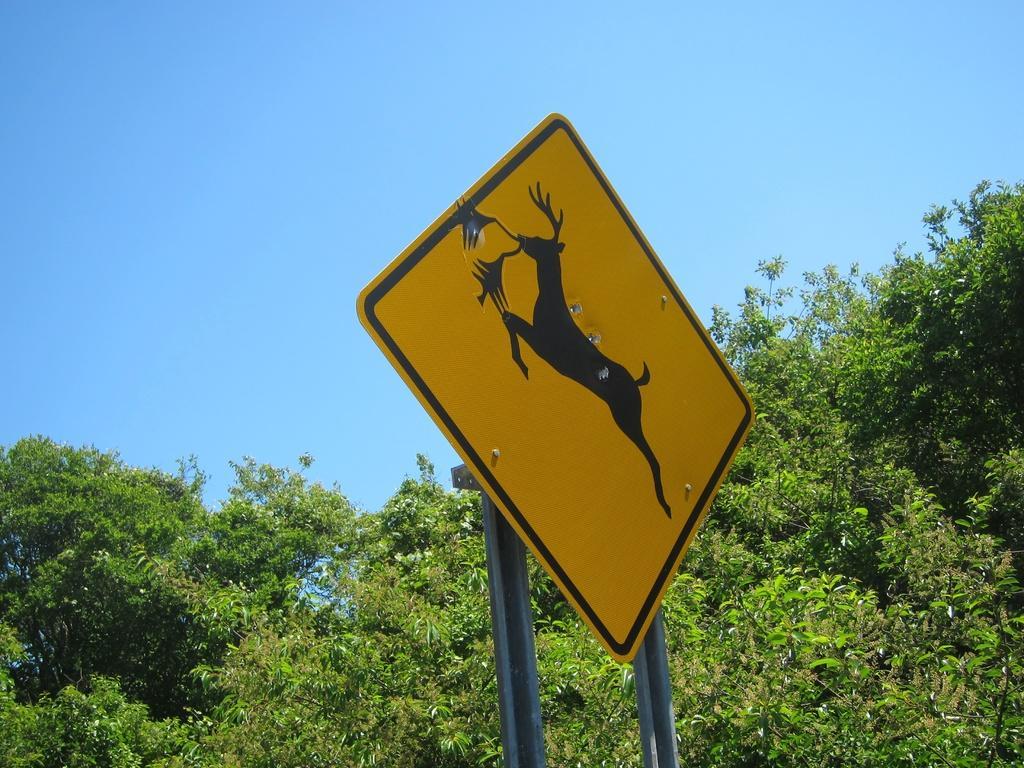Please provide a concise description of this image. In this image we can see sky, trees and a board. 